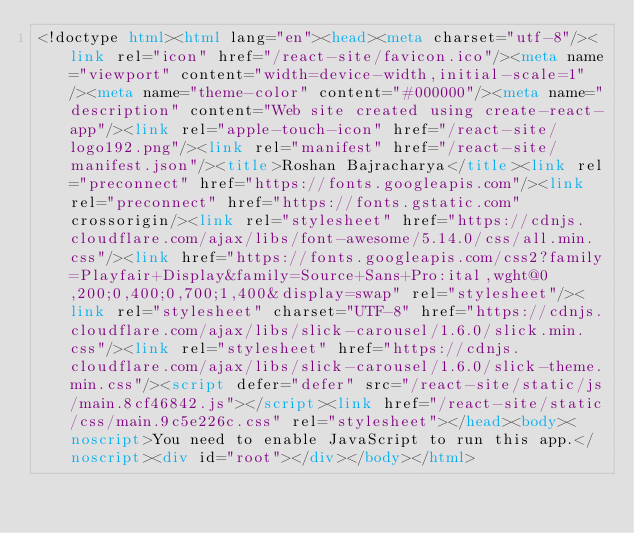<code> <loc_0><loc_0><loc_500><loc_500><_HTML_><!doctype html><html lang="en"><head><meta charset="utf-8"/><link rel="icon" href="/react-site/favicon.ico"/><meta name="viewport" content="width=device-width,initial-scale=1"/><meta name="theme-color" content="#000000"/><meta name="description" content="Web site created using create-react-app"/><link rel="apple-touch-icon" href="/react-site/logo192.png"/><link rel="manifest" href="/react-site/manifest.json"/><title>Roshan Bajracharya</title><link rel="preconnect" href="https://fonts.googleapis.com"/><link rel="preconnect" href="https://fonts.gstatic.com" crossorigin/><link rel="stylesheet" href="https://cdnjs.cloudflare.com/ajax/libs/font-awesome/5.14.0/css/all.min.css"/><link href="https://fonts.googleapis.com/css2?family=Playfair+Display&family=Source+Sans+Pro:ital,wght@0,200;0,400;0,700;1,400&display=swap" rel="stylesheet"/><link rel="stylesheet" charset="UTF-8" href="https://cdnjs.cloudflare.com/ajax/libs/slick-carousel/1.6.0/slick.min.css"/><link rel="stylesheet" href="https://cdnjs.cloudflare.com/ajax/libs/slick-carousel/1.6.0/slick-theme.min.css"/><script defer="defer" src="/react-site/static/js/main.8cf46842.js"></script><link href="/react-site/static/css/main.9c5e226c.css" rel="stylesheet"></head><body><noscript>You need to enable JavaScript to run this app.</noscript><div id="root"></div></body></html></code> 